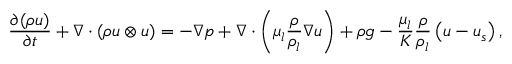<formula> <loc_0><loc_0><loc_500><loc_500>\frac { \partial ( \rho u ) } { \partial t } + \nabla \cdot ( \rho u \otimes u ) = - \nabla p + \nabla \cdot \left ( \mu _ { l } \frac { \rho } { \rho _ { l } } \nabla u \right ) + \rho g - \frac { \mu _ { l } } { K } \frac { \rho } { \rho _ { l } } \left ( u - u _ { s } \right ) ,</formula> 